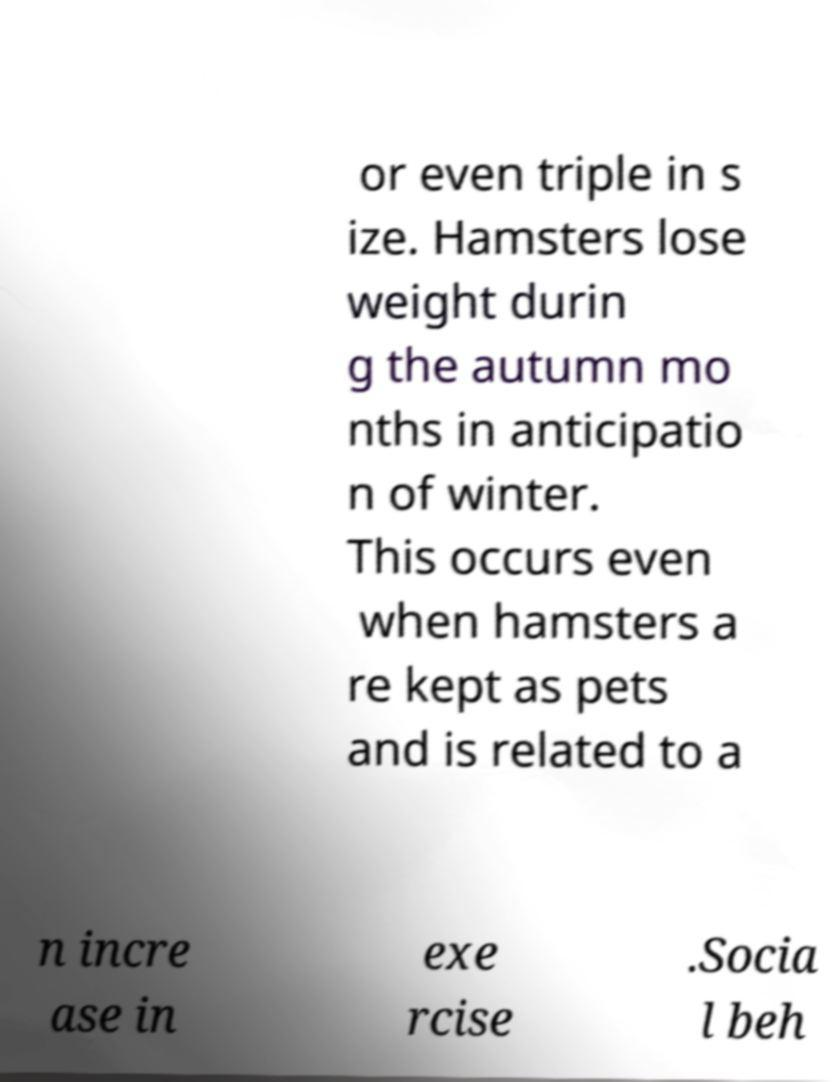Please read and relay the text visible in this image. What does it say? or even triple in s ize. Hamsters lose weight durin g the autumn mo nths in anticipatio n of winter. This occurs even when hamsters a re kept as pets and is related to a n incre ase in exe rcise .Socia l beh 